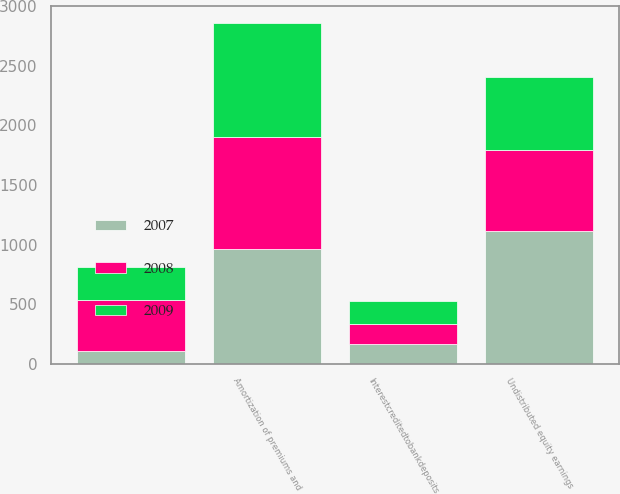Convert chart to OTSL. <chart><loc_0><loc_0><loc_500><loc_500><stacked_bar_chart><ecel><fcel>Unnamed: 1<fcel>Amortization of premiums and<fcel>Undistributed equity earnings<fcel>Interestcreditedtobankdeposits<nl><fcel>2007<fcel>110<fcel>967<fcel>1118<fcel>163<nl><fcel>2008<fcel>428<fcel>939<fcel>679<fcel>166<nl><fcel>2009<fcel>275<fcel>955<fcel>606<fcel>200<nl></chart> 